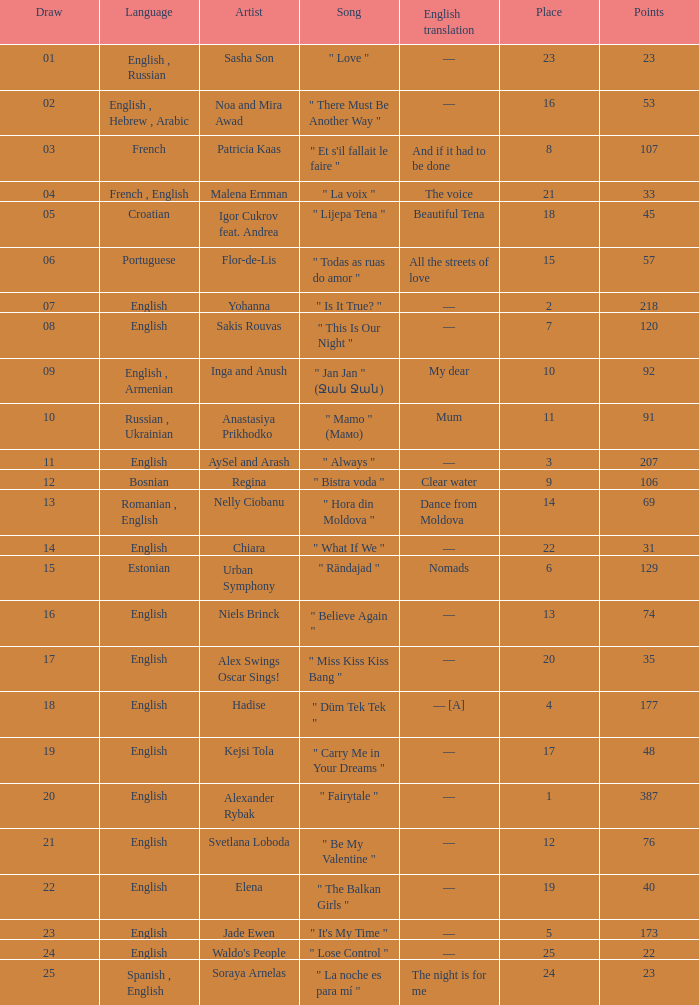Which song was in the french language? " Et s'il fallait le faire ". 